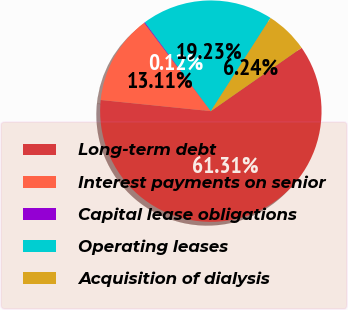<chart> <loc_0><loc_0><loc_500><loc_500><pie_chart><fcel>Long-term debt<fcel>Interest payments on senior<fcel>Capital lease obligations<fcel>Operating leases<fcel>Acquisition of dialysis<nl><fcel>61.32%<fcel>13.11%<fcel>0.12%<fcel>19.23%<fcel>6.24%<nl></chart> 